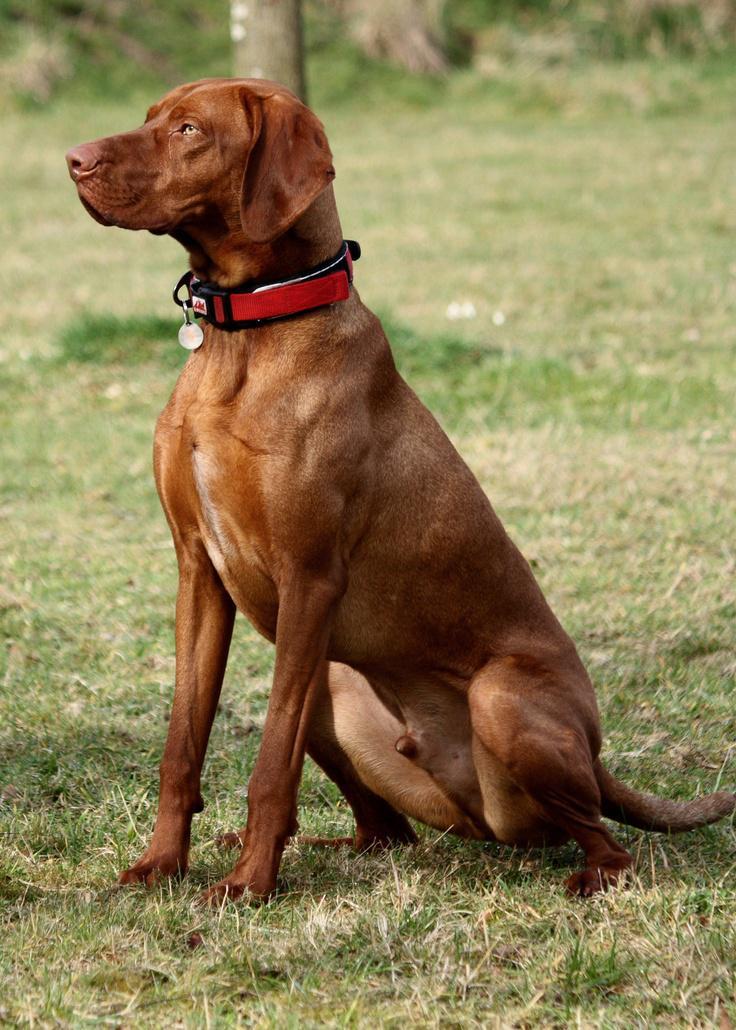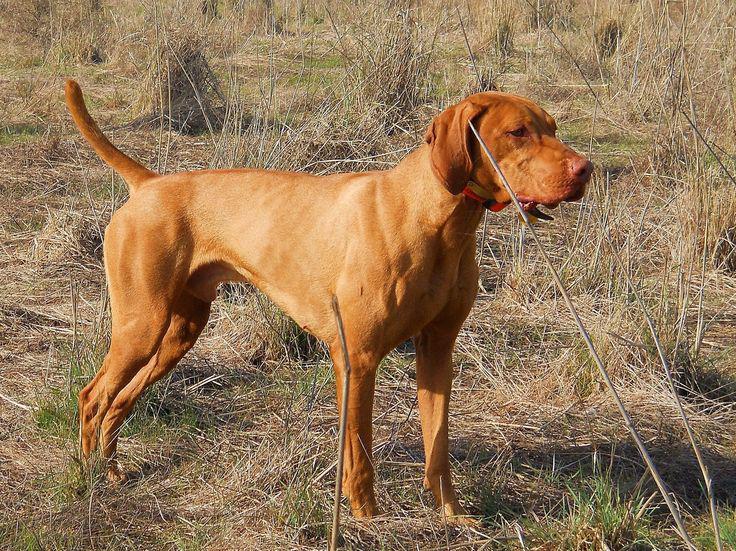The first image is the image on the left, the second image is the image on the right. Analyze the images presented: Is the assertion "Each image shows a single dog that is outside and wearing a collar." valid? Answer yes or no. Yes. The first image is the image on the left, the second image is the image on the right. Assess this claim about the two images: "The left image contains one dog sitting upright, and the right image contains one dog standing on all fours.". Correct or not? Answer yes or no. Yes. 